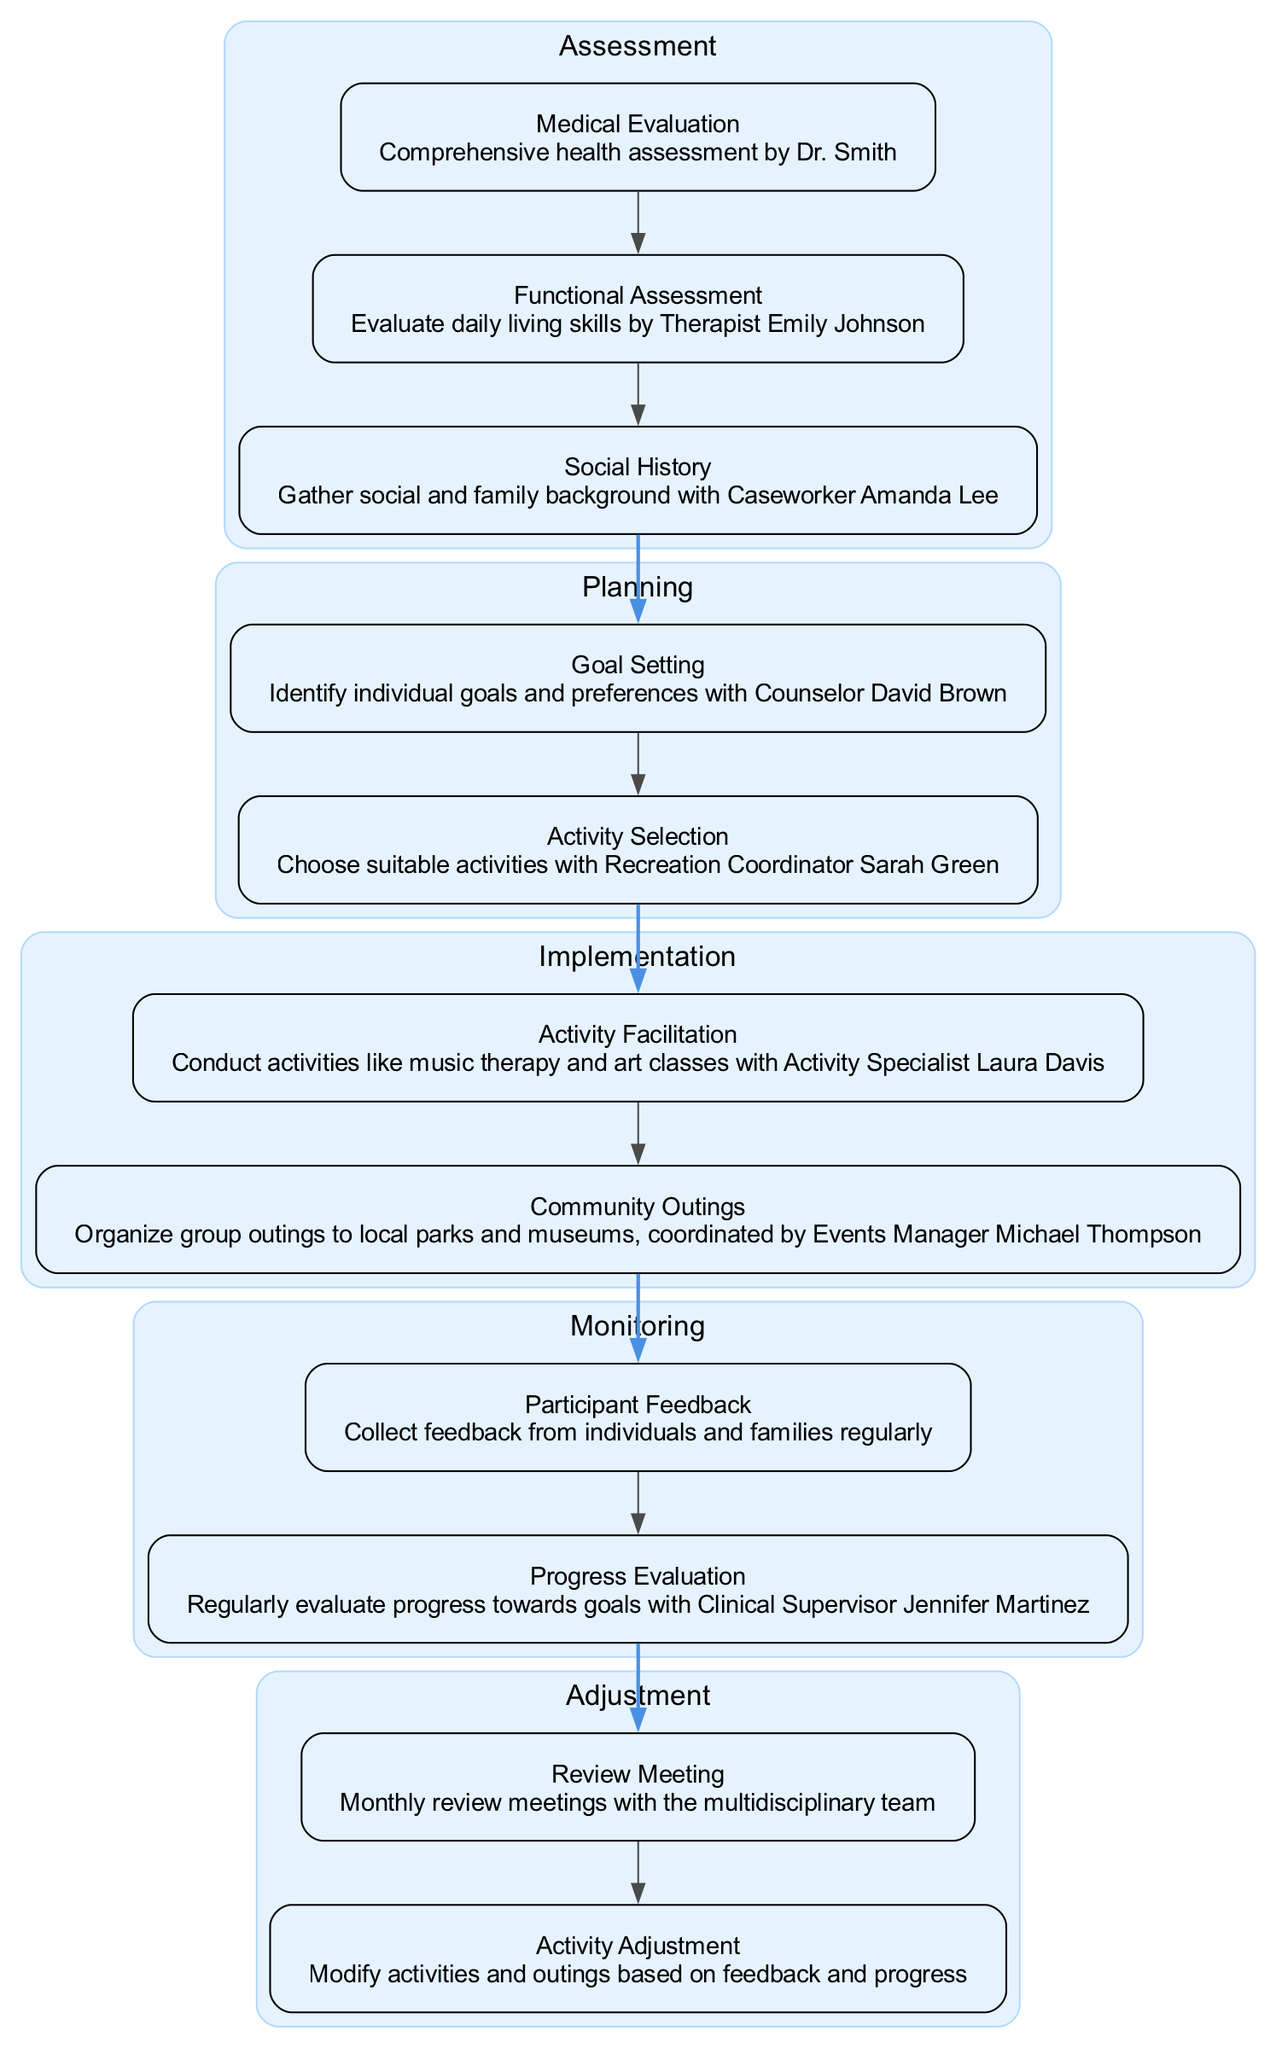What is the first stage in the clinical pathway? The first stage listed in the diagram is "Assessment," which introduces the initial phase of evaluating the individual’s needs.
Answer: Assessment How many elements are in the Planning stage? In the Planning stage, there are two elements: "Goal Setting" and "Activity Selection."
Answer: 2 Who conducts the activities during the Implementation stage? The activities are facilitated by "Activity Specialist Laura Davis," who is responsible for conducting various activities.
Answer: Activity Specialist Laura Davis What is the purpose of the Review Meeting in the Adjustment stage? The "Review Meeting" serves as a platform for the multidisciplinary team to discuss progress and adjustments to the plan.
Answer: Progress discussion How many stages are present in the clinical pathway? The clinical pathway consists of five distinct stages, including Assessment, Planning, Implementation, Monitoring, and Adjustment.
Answer: 5 What is the last element of the Implementation stage? The last element in the Implementation stage is "Community Outings," which are organized group activities outside the main facility.
Answer: Community Outings Which element collects feedback from participants? The element titled "Participant Feedback" is responsible for gathering insights from individuals and their families.
Answer: Participant Feedback How are goals identified in the Planning stage? Goals are identified through the "Goal Setting" element, which is done in collaboration with Counselor David Brown.
Answer: Counselor David Brown Which stage follows Monitoring? The stage that follows Monitoring is "Adjustment," indicating a transition to reviewing and modifying the plan based on progress.
Answer: Adjustment 